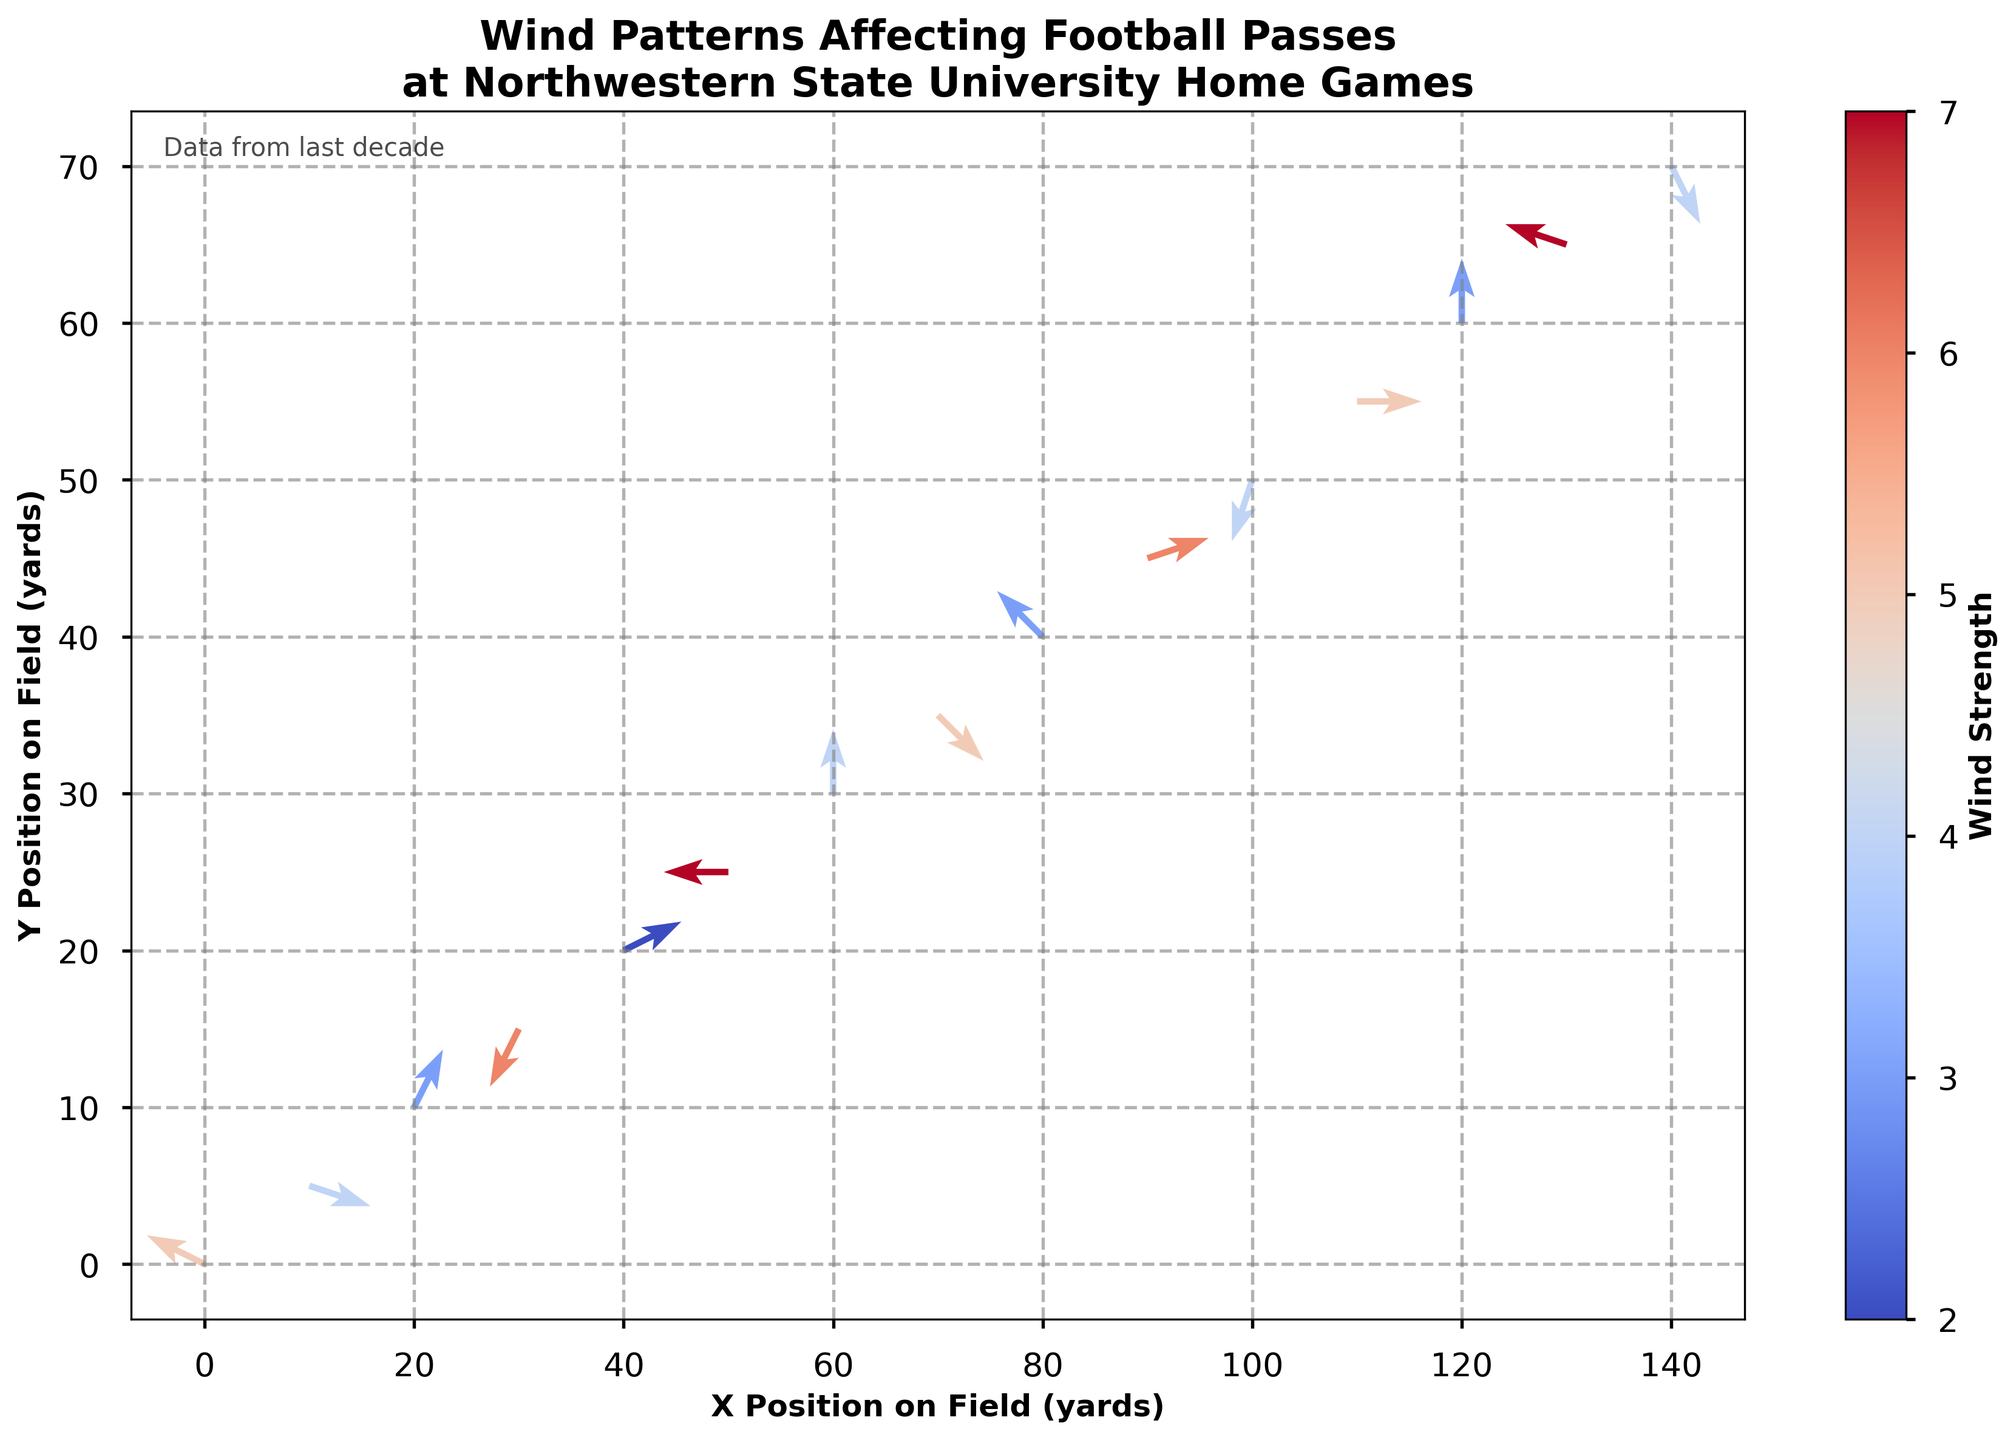What is the title of the figure? The title of the figure is prominently displayed at the top, indicating what the plot represents.
Answer: Wind Patterns Affecting Football Passes at Northwestern State University Home Games How many vectors are displayed in the plot? The figure shows vectors at specific (x, y) positions. Counting these positions will give the number of vectors. There are vectors shown at 15 positions.
Answer: 15 Which direction is most common for wind arrows on the field? By looking at the orientation of the arrows in the figure, the direction that appears most frequently for the wind can be identified. Most arrows point in the negative x-axis direction.
Answer: Negative x-axis What is the range of wind strength shown in the color bar? The color bar on the right side of the plot indicates the range of values for wind strength.
Answer: 2 to 7 Which area of the field experiences the strongest wind strength? By examining the color of the arrows and comparing them to the color bar, the region of the field with the highest wind strength can be identified. The arrows around (50, 25) have the strongest wind strength.
Answer: Around (50, 25) Which position on the field has the weakest wind strength? By identifying the lightest colored arrows (indicating the lowest wind strength) and reading their (x, y) position, the position with the weakest wind can be determined.
Answer: (40, 20) Is there any position where the wind is blowing directly upwards? For this, we need to find any arrow that points exactly along the positive Y-axis (vertical direction). The arrow at (60, 30) points directly upwards.
Answer: (60, 30) How does the wind pattern change from (30, 15) to (50, 25)? This question requires comparing the arrows at these two positions in terms of direction and magnitude using the plot. The wind at (30, 15) is blowing towards the south-west, while at (50, 25), it is blowing directly towards the west.
Answer: From south-west to west Which area shows a significant change in wind direction and strength compared to its neighboring points? Inspecting the plot for any prominent change in direction and color of wind arrows between neighboring positions will identify this area. The area around (90, 45) shows significant changes in both direction and strength compared to neighboring points.
Answer: Around (90, 45) What are the (x, y) coordinates where wind is blowing downwards with no horizontal movement? To answer this, find the arrow pointing directly negative along the Y-axis (downwards) without any horizontal component. This is found at (100, 50).
Answer: (100, 50) 